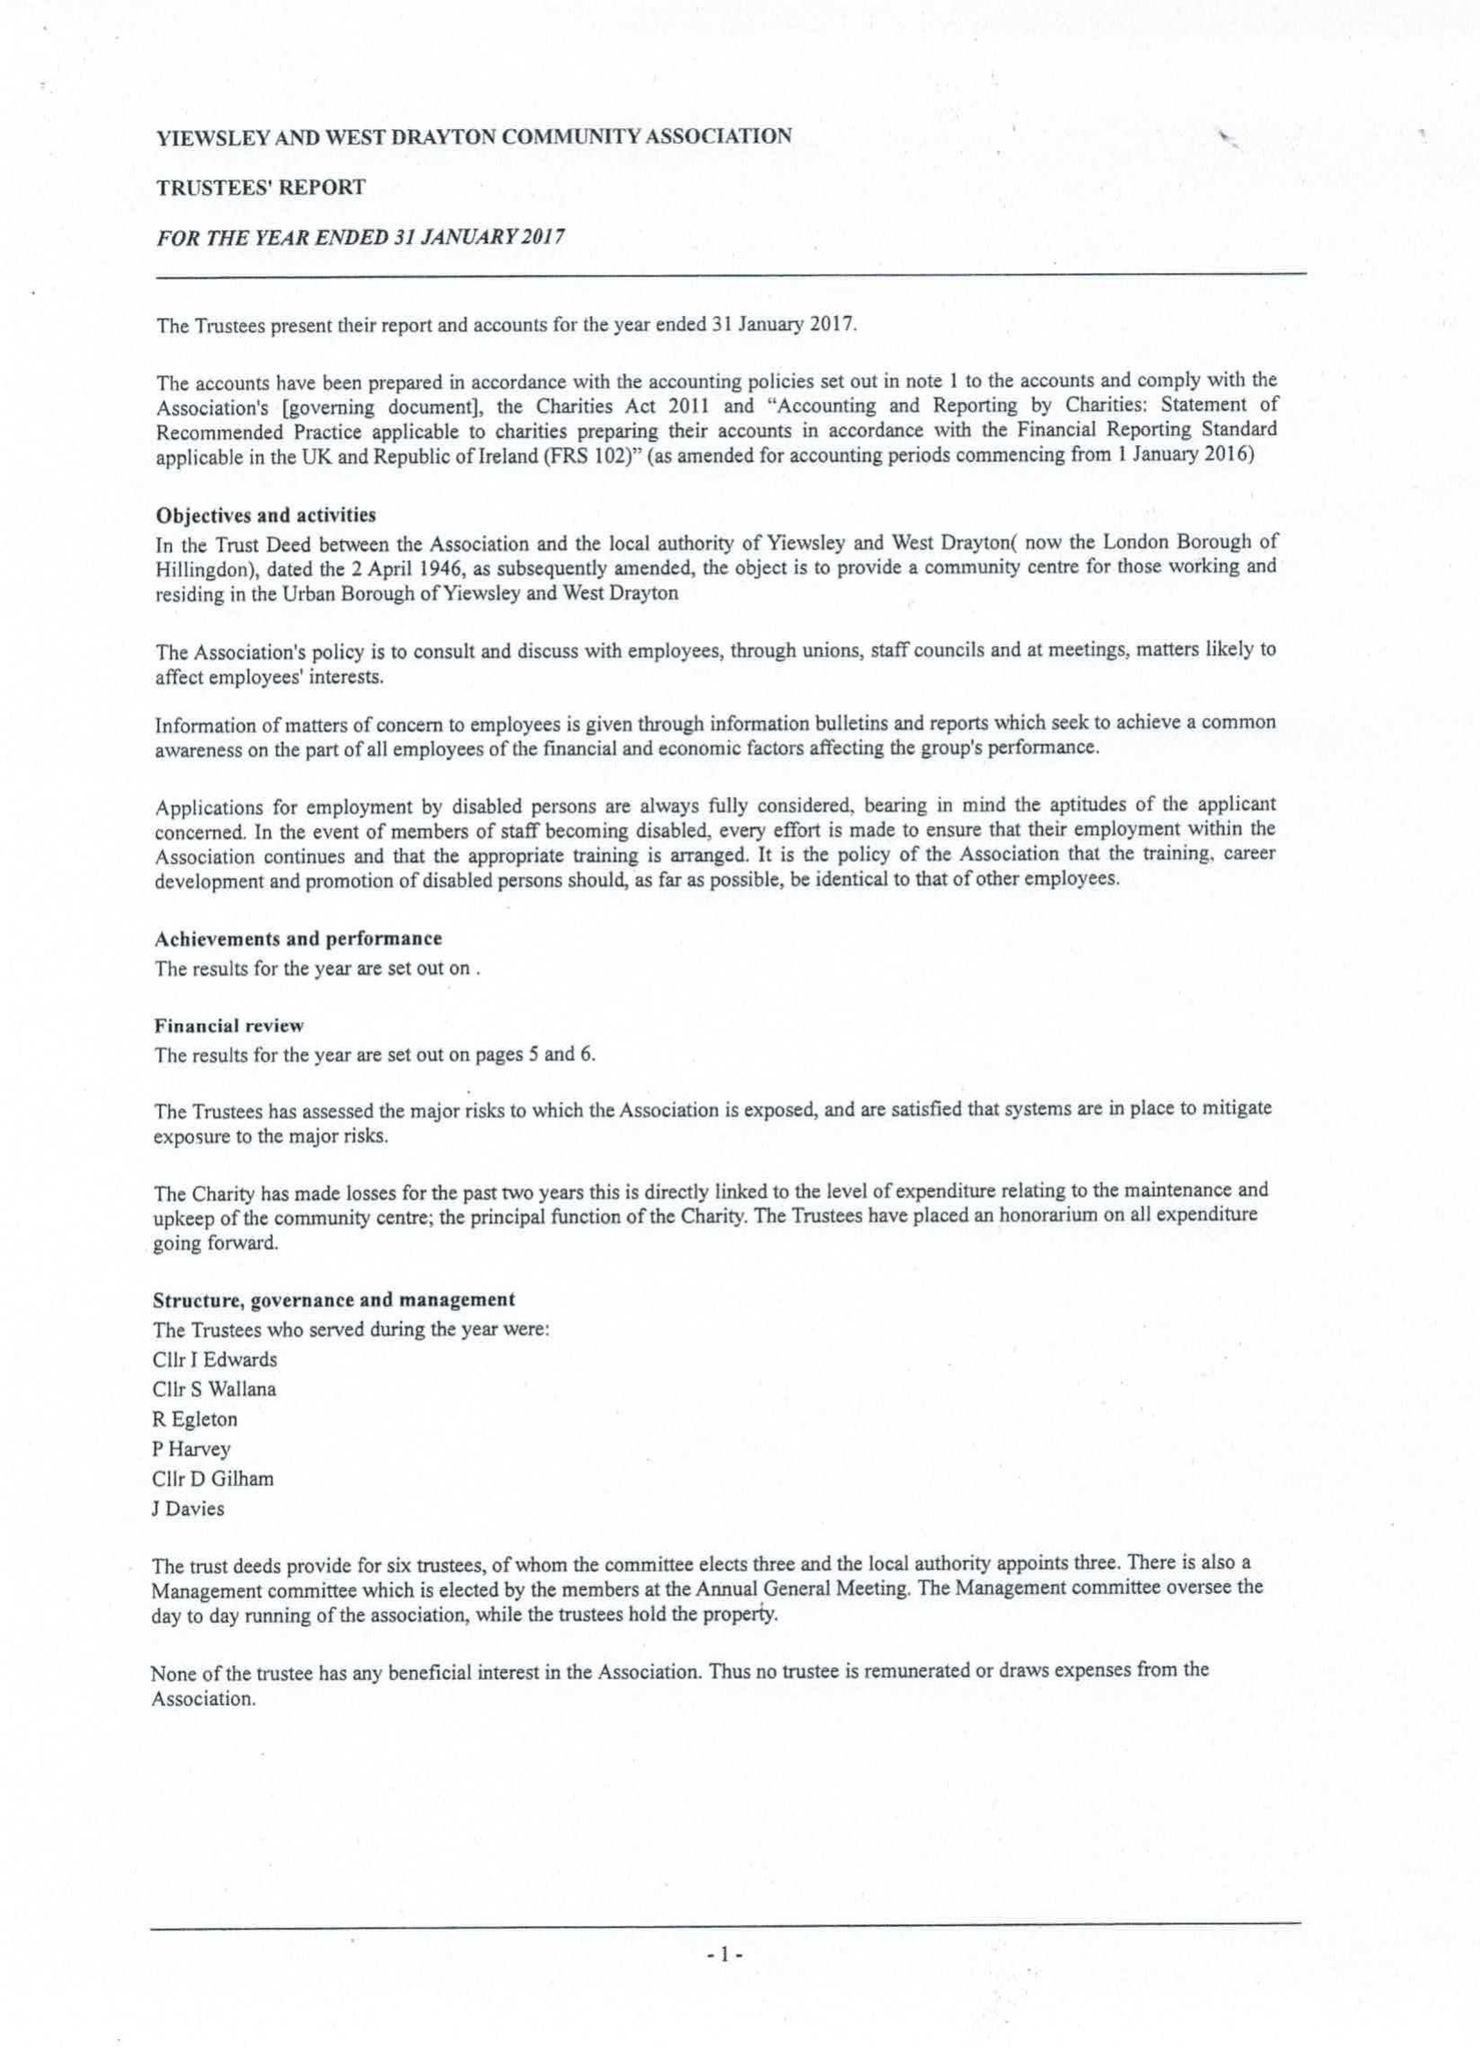What is the value for the report_date?
Answer the question using a single word or phrase. 2017-01-31 